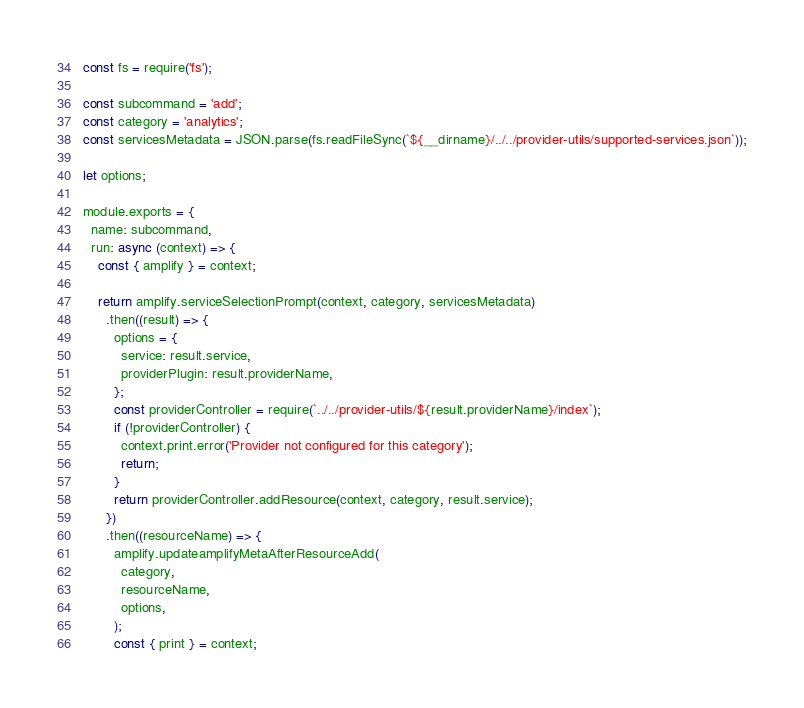Convert code to text. <code><loc_0><loc_0><loc_500><loc_500><_JavaScript_>const fs = require('fs');

const subcommand = 'add';
const category = 'analytics';
const servicesMetadata = JSON.parse(fs.readFileSync(`${__dirname}/../../provider-utils/supported-services.json`));

let options;

module.exports = {
  name: subcommand,
  run: async (context) => {
    const { amplify } = context;

    return amplify.serviceSelectionPrompt(context, category, servicesMetadata)
      .then((result) => {
        options = {
          service: result.service,
          providerPlugin: result.providerName,
        };
        const providerController = require(`../../provider-utils/${result.providerName}/index`);
        if (!providerController) {
          context.print.error('Provider not configured for this category');
          return;
        }
        return providerController.addResource(context, category, result.service);
      })
      .then((resourceName) => {
        amplify.updateamplifyMetaAfterResourceAdd(
          category,
          resourceName,
          options,
        );
        const { print } = context;</code> 